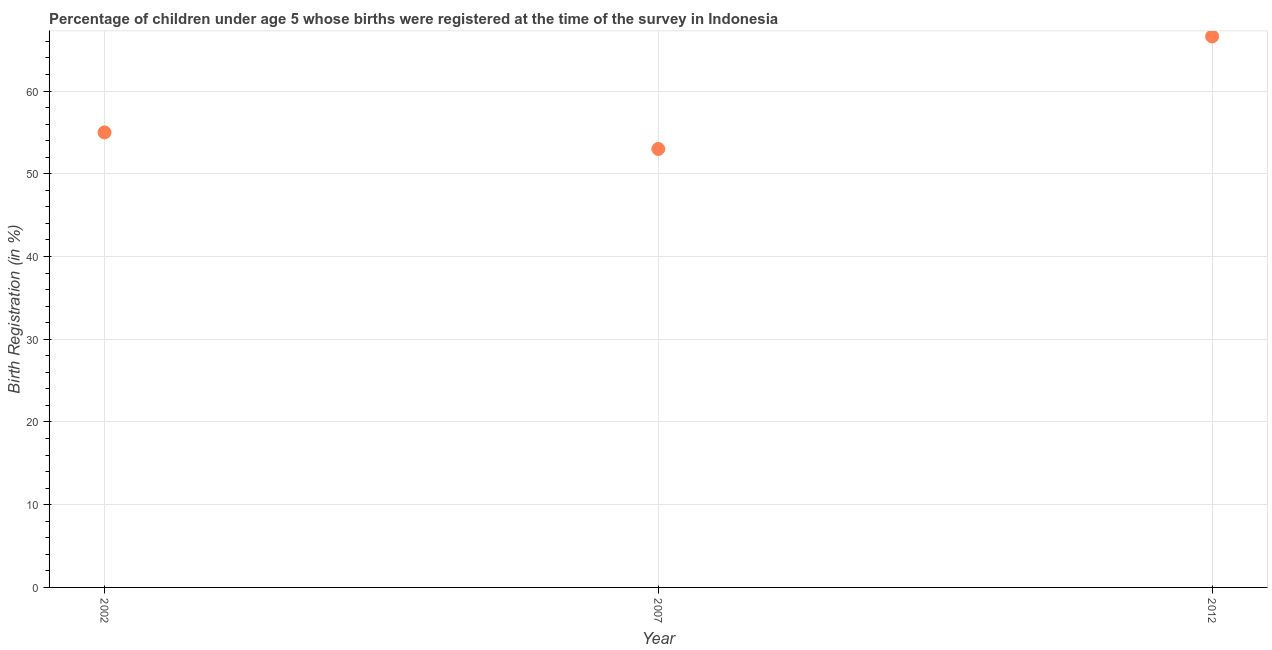What is the birth registration in 2007?
Offer a terse response. 53. Across all years, what is the maximum birth registration?
Ensure brevity in your answer.  66.6. Across all years, what is the minimum birth registration?
Make the answer very short. 53. In which year was the birth registration minimum?
Your answer should be compact. 2007. What is the sum of the birth registration?
Offer a terse response. 174.6. What is the difference between the birth registration in 2007 and 2012?
Your answer should be very brief. -13.6. What is the average birth registration per year?
Offer a very short reply. 58.2. What is the median birth registration?
Give a very brief answer. 55. In how many years, is the birth registration greater than 52 %?
Keep it short and to the point. 3. Do a majority of the years between 2012 and 2002 (inclusive) have birth registration greater than 44 %?
Your answer should be compact. No. What is the ratio of the birth registration in 2007 to that in 2012?
Provide a succinct answer. 0.8. Is the birth registration in 2007 less than that in 2012?
Provide a short and direct response. Yes. What is the difference between the highest and the second highest birth registration?
Offer a terse response. 11.6. What is the difference between the highest and the lowest birth registration?
Your answer should be very brief. 13.6. How many dotlines are there?
Provide a succinct answer. 1. What is the difference between two consecutive major ticks on the Y-axis?
Your answer should be very brief. 10. Does the graph contain any zero values?
Keep it short and to the point. No. What is the title of the graph?
Make the answer very short. Percentage of children under age 5 whose births were registered at the time of the survey in Indonesia. What is the label or title of the X-axis?
Your answer should be compact. Year. What is the label or title of the Y-axis?
Provide a succinct answer. Birth Registration (in %). What is the Birth Registration (in %) in 2012?
Make the answer very short. 66.6. What is the difference between the Birth Registration (in %) in 2002 and 2012?
Your answer should be compact. -11.6. What is the difference between the Birth Registration (in %) in 2007 and 2012?
Your answer should be very brief. -13.6. What is the ratio of the Birth Registration (in %) in 2002 to that in 2007?
Provide a succinct answer. 1.04. What is the ratio of the Birth Registration (in %) in 2002 to that in 2012?
Make the answer very short. 0.83. What is the ratio of the Birth Registration (in %) in 2007 to that in 2012?
Offer a very short reply. 0.8. 